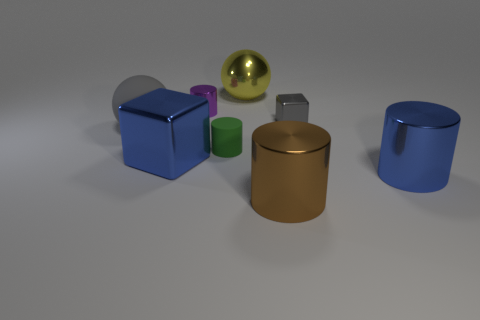Subtract all brown spheres. Subtract all cyan cylinders. How many spheres are left? 2 Add 1 red metallic cylinders. How many objects exist? 9 Subtract all spheres. How many objects are left? 6 Add 2 purple shiny cylinders. How many purple shiny cylinders exist? 3 Subtract 1 blue cylinders. How many objects are left? 7 Subtract all tiny gray metal spheres. Subtract all rubber things. How many objects are left? 6 Add 8 big yellow things. How many big yellow things are left? 9 